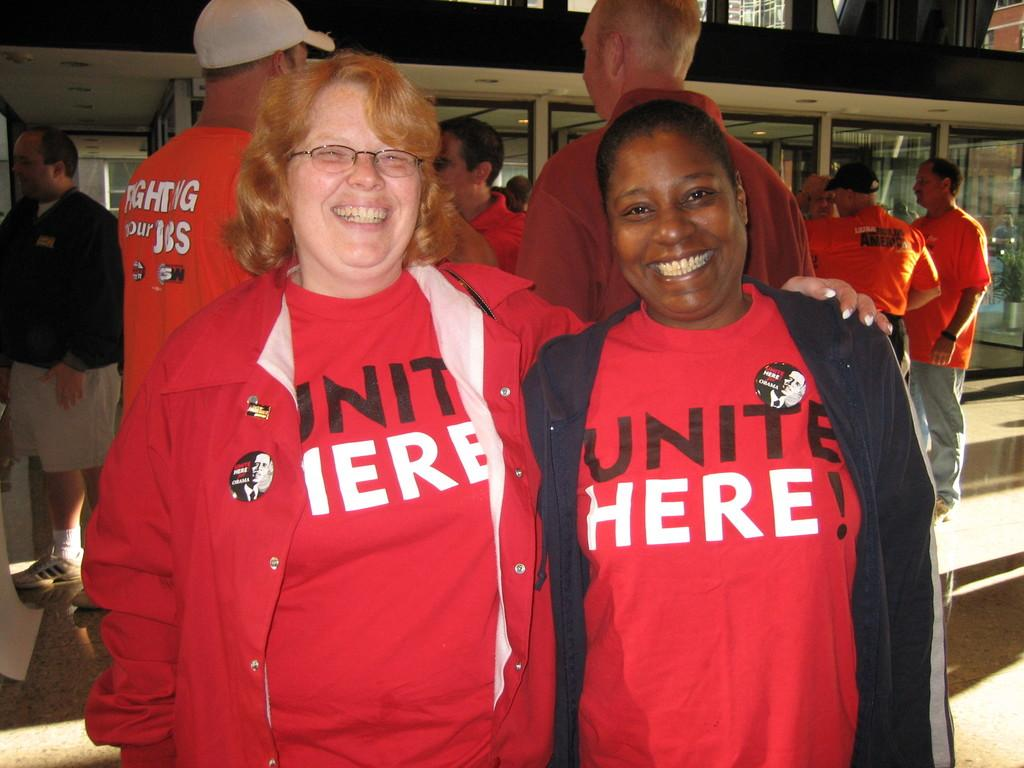<image>
Write a terse but informative summary of the picture. Two women in red shirts that say United Here. 